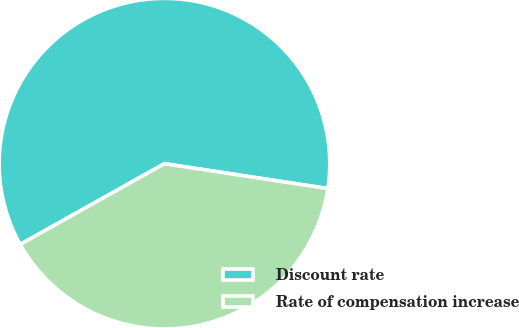<chart> <loc_0><loc_0><loc_500><loc_500><pie_chart><fcel>Discount rate<fcel>Rate of compensation increase<nl><fcel>60.53%<fcel>39.47%<nl></chart> 